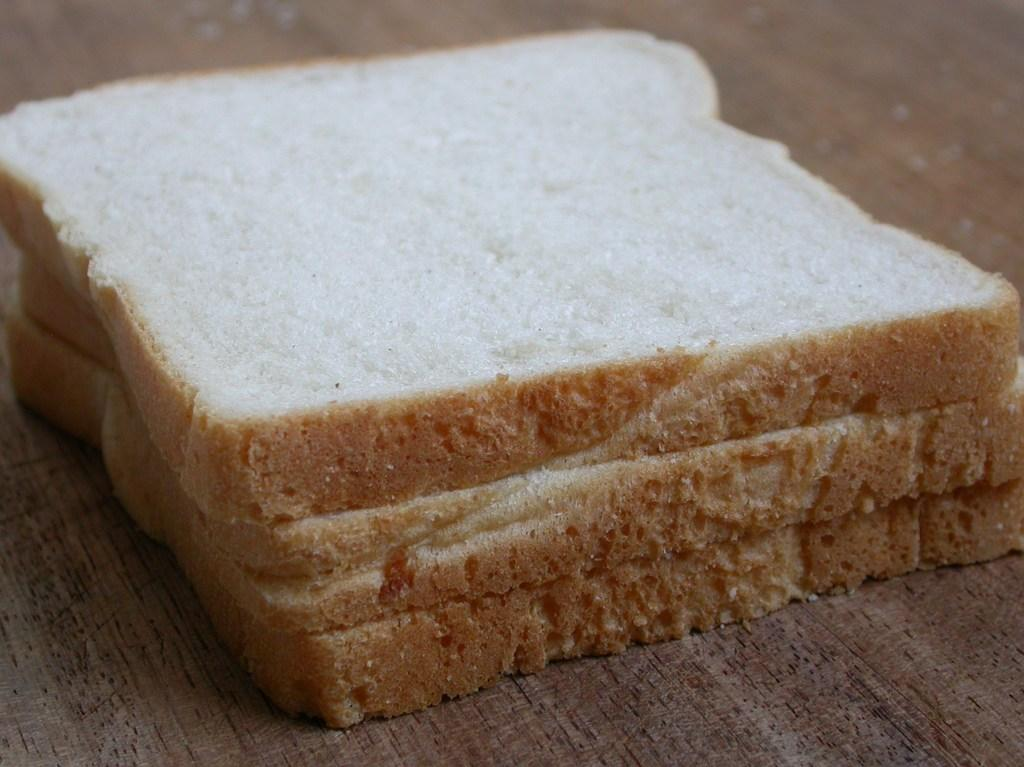What type of food can be seen in the image? There are bread slices in the image. Where are the bread slices located? The bread slices are on a wooden table. What type of stick can be seen in the image? There is no stick present in the image; it only features bread slices on a wooden table. 